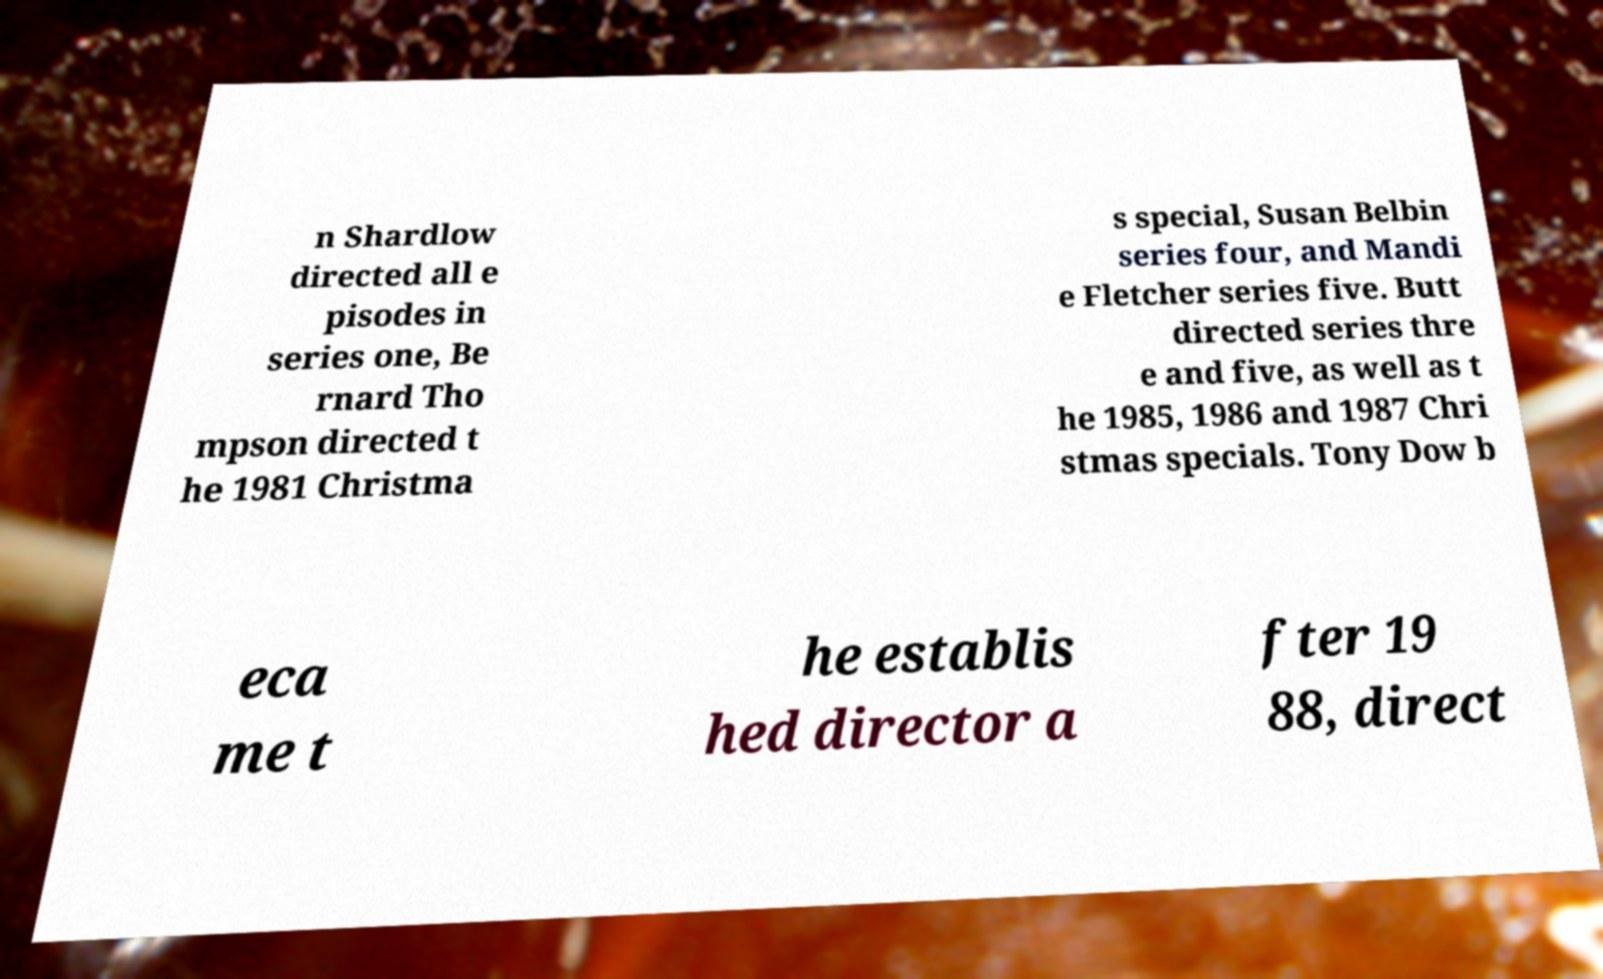Please identify and transcribe the text found in this image. n Shardlow directed all e pisodes in series one, Be rnard Tho mpson directed t he 1981 Christma s special, Susan Belbin series four, and Mandi e Fletcher series five. Butt directed series thre e and five, as well as t he 1985, 1986 and 1987 Chri stmas specials. Tony Dow b eca me t he establis hed director a fter 19 88, direct 